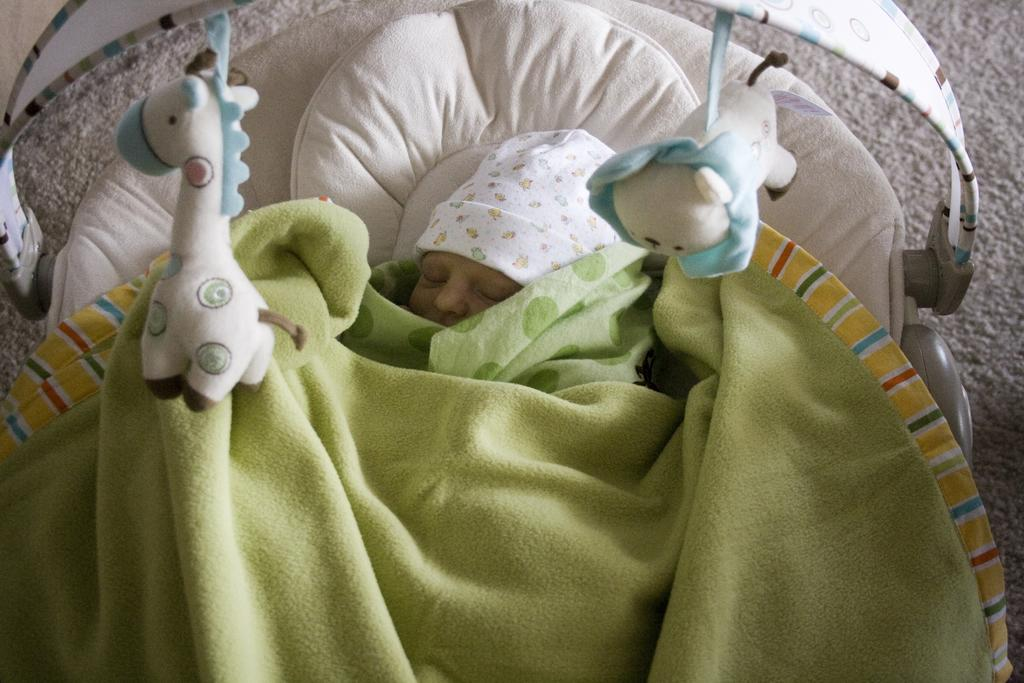What is the main subject in the center of the image? There is a baby in the center of the image. What is the baby doing in the image? The baby is sleeping. What items are present to provide comfort to the baby? There are blankets and pillows in the image. What can be seen for the baby to play with? There are toys in the image. What is the surface beneath the baby? There is a carpet at the bottom of the image. How many trucks can be seen driving on the carpet in the image? There are no trucks visible in the image; it features a baby sleeping with toys and blankets. What type of frogs are present in the image? There are no frogs present in the image. 